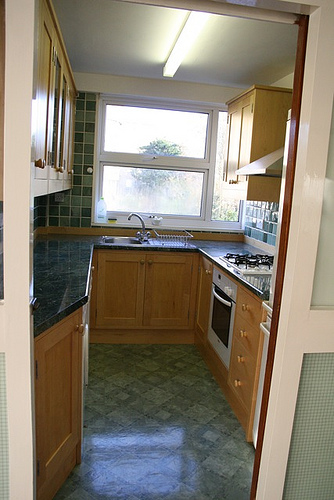What's a realistic daily scenario that takes place in this kitchen? A typical day in this kitchen starts with the morning routine: someone opens the tall cabinet to grab cereal, while another family member fills the kettle at the sink to make tea. The kitchen becomes the hub of the house, with quick breakfasts prepared at the stove, lunchboxes assembled on the countertop, and dinner cooked in the oven. The space is alive with activity, from the early morning rush to late-night snacks.  Briefly describe an evening in this kitchen. In the evening, the kitchen is filled with the aroma of a delicious dinner cooking on the stove. Someone is chopping vegetables at the countertop, while another person sets the table nearby. The window above the sink reflects the warm glow of the overhead light, creating a cozy atmosphere perfect for a family meal. 